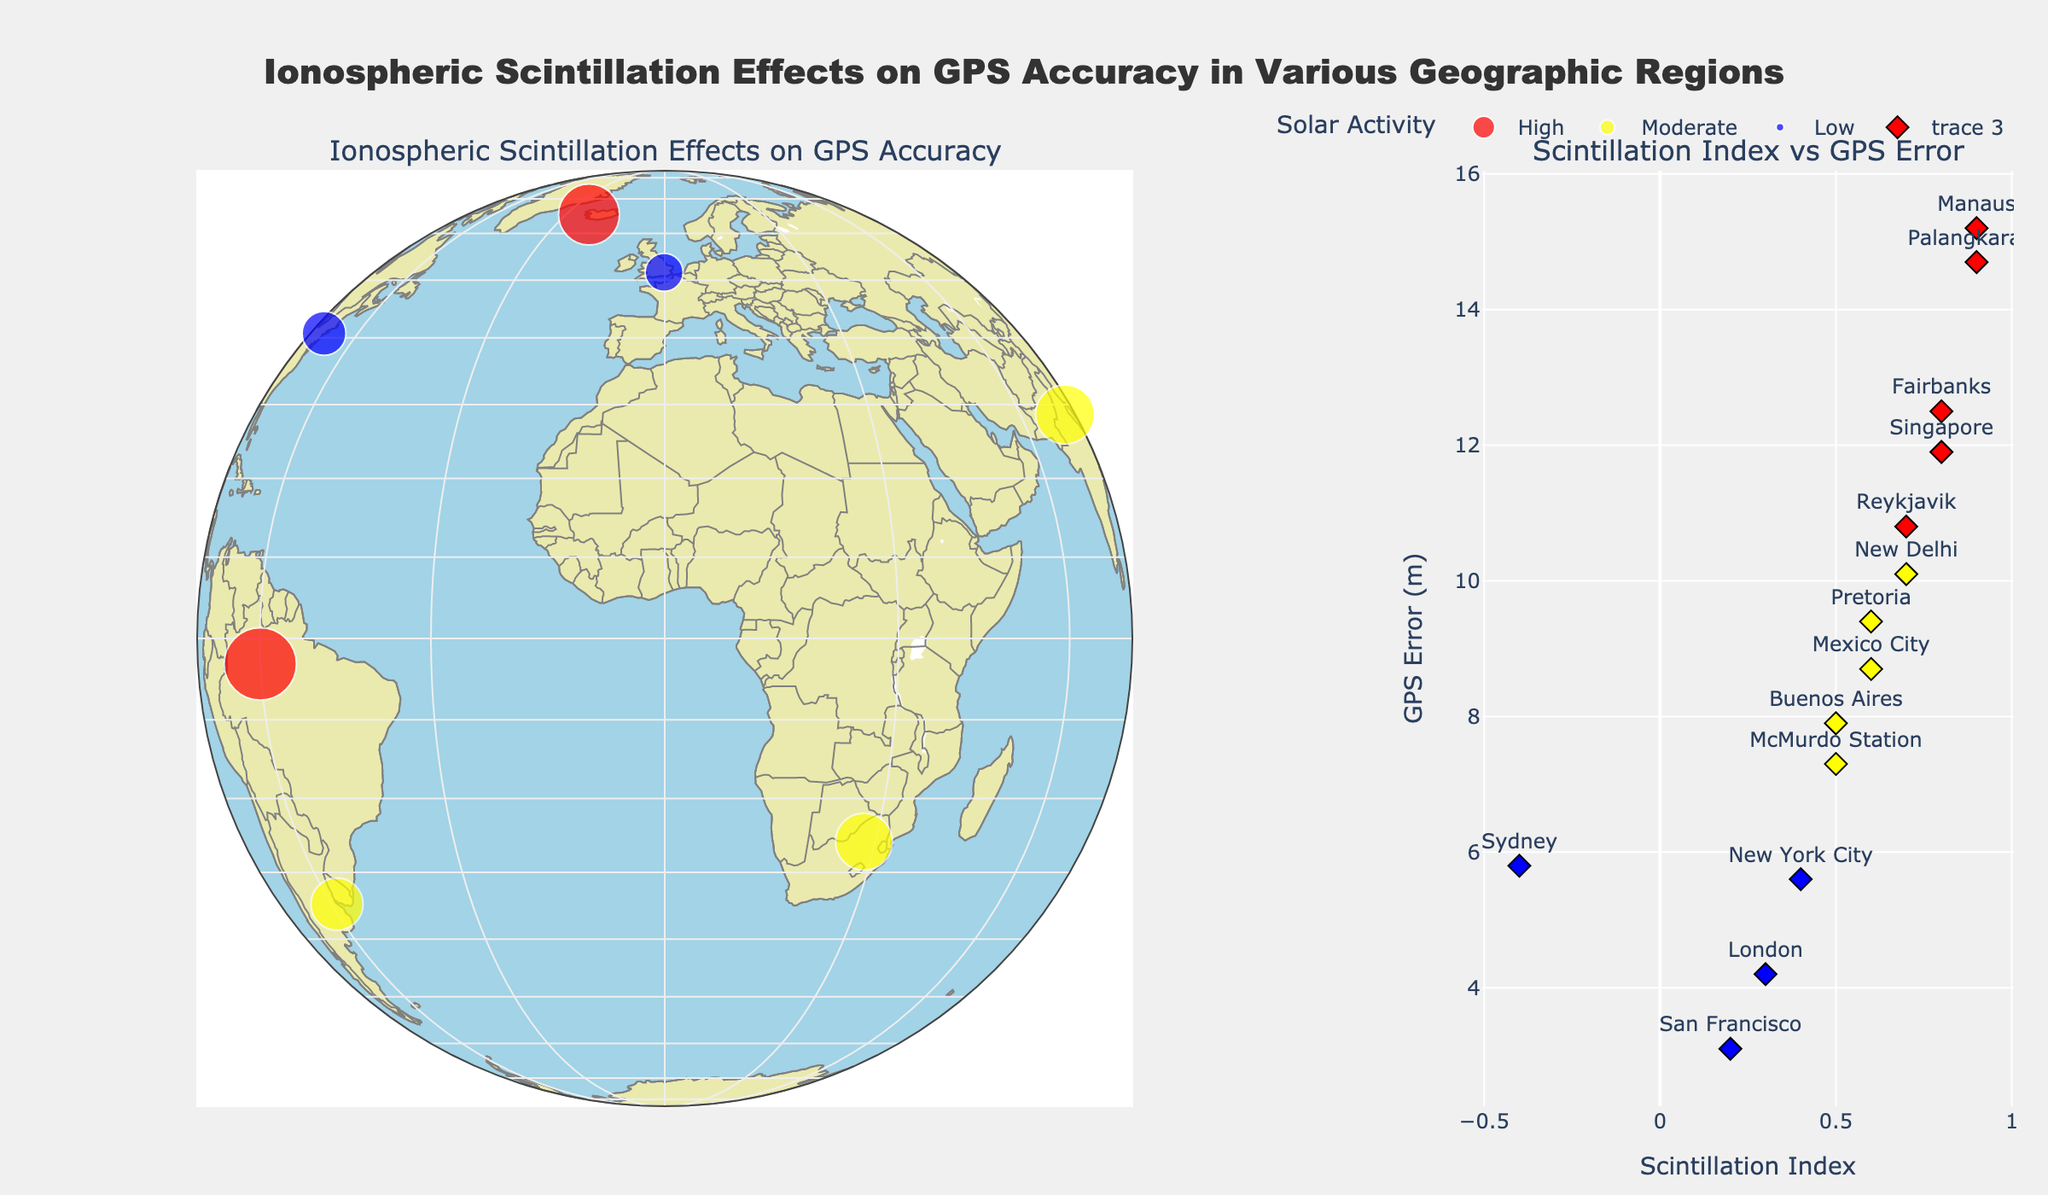What is the title of the plot? The title is located at the top of the plot and is usually displayed prominently. It gives an overview of what the plot represents.
Answer: Ionospheric Scintillation Effects on GPS Accuracy in Various Geographic Regions What color represents 'High' solar activity? The color representing 'High' solar activity can be observed on the legend and in the scatter geo plot. The plot uses 'red' for regions with high solar activity.
Answer: Red Which region has the highest GPS error in meters and what is its scintillation index? By observing the scatter geo plot and the scatter plot, the region with the largest marker size (indicating higher GPS error) and the corresponding scintillation index can be found. Manaus has the highest GPS error with a scintillation index of 0.9.
Answer: Manaus, 0.9 What is the relationship between scintillation index and GPS error in the scatter plot? The scatter plot on the right side shows the relationship between the scintillation index (x-axis) and GPS error (y-axis). By inspecting the trend, it appears that higher scintillation indices correspond to higher GPS errors.
Answer: Positive correlation How many regions have a scintillation index greater than 0.5? By reviewing the scatter plot, count the number of data points that are located to the right of the 0.5 mark on the x-axis. There are eight regions with a scintillation index greater than 0.5.
Answer: Eight Which regions experience low solar activity and what are their GPS errors? By referring to the color legend and the markers colored in blue (representing 'Low' solar activity), we can identify the regions with low solar activity and read their associated GPS errors. The regions are London (4.2 m), Sydney (5.8 m), and San Francisco (3.1 m).
Answer: London (4.2 m), Sydney (5.8 m), San Francisco (3.1 m) Which region has the lowest scintillation index and what is the corresponding GPS error? By identifying the smallest value on the x-axis (Scintillation Index) in the scatter plot, the region with the lowest index and its GPS error can be determined. The lowest scintillation index is in Sydney with a value of -0.4 and a GPS error of 5.8 m.
Answer: Sydney, 5.8 m Compare Fairbanks and Reykjavik: Which has a higher scintillation index and GPS error? By finding both regions on the scatter plot, compare their scintillation indices and GPS errors. Fairbanks has a scintillation index of 0.8 and a GPS error of 12.5 m, whereas Reykjavik has a scintillation index of 0.7 and a GPS error of 10.8 m.
Answer: Fairbanks What is the average GPS error for regions with high solar activity? Identify the regions with 'High' solar activity (red markers) and then calculate the average of their GPS errors. The regions are Fairbanks (12.5 m), Manaus (15.2 m), Singapore (11.9 m), Reykjavik (10.8 m), and Palangkaraya (14.7 m). The average is (12.5 + 15.2 + 11.9 + 10.8 + 14.7) / 5 = 13.0 m.
Answer: 13.0 m In which subplot is the projection type displayed, and what type of projection is it? The projection type is referenced in the scatter geo plot, visible in the left subplot. The projection type used is "natural earth."
Answer: Scatter geo plot, natural earth 